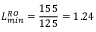Convert formula to latex. <formula><loc_0><loc_0><loc_500><loc_500>L _ { \min } ^ { R O } = \frac { 1 5 5 } { 1 2 5 } = 1 . 2 4</formula> 